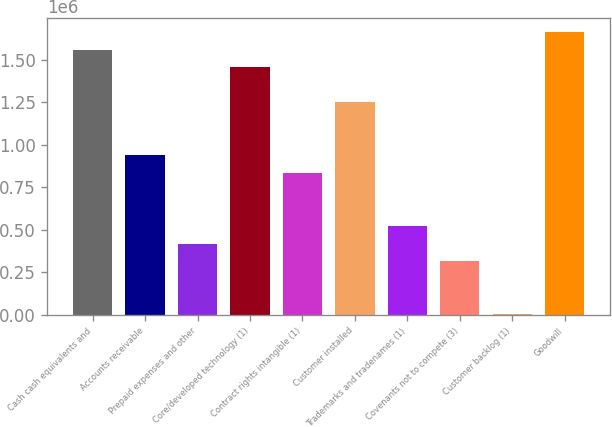Convert chart to OTSL. <chart><loc_0><loc_0><loc_500><loc_500><bar_chart><fcel>Cash cash equivalents and<fcel>Accounts receivable<fcel>Prepaid expenses and other<fcel>Core/developed technology (1)<fcel>Contract rights intangible (1)<fcel>Customer installed<fcel>Trademarks and tradenames (1)<fcel>Covenants not to compete (3)<fcel>Customer backlog (1)<fcel>Goodwill<nl><fcel>1.56182e+06<fcel>937932<fcel>418025<fcel>1.45784e+06<fcel>833950<fcel>1.24988e+06<fcel>522006<fcel>314044<fcel>2100<fcel>1.6658e+06<nl></chart> 